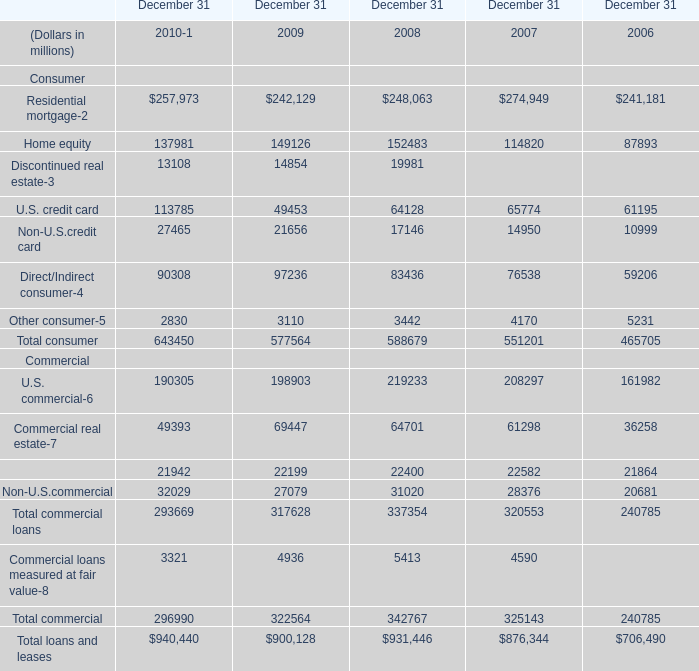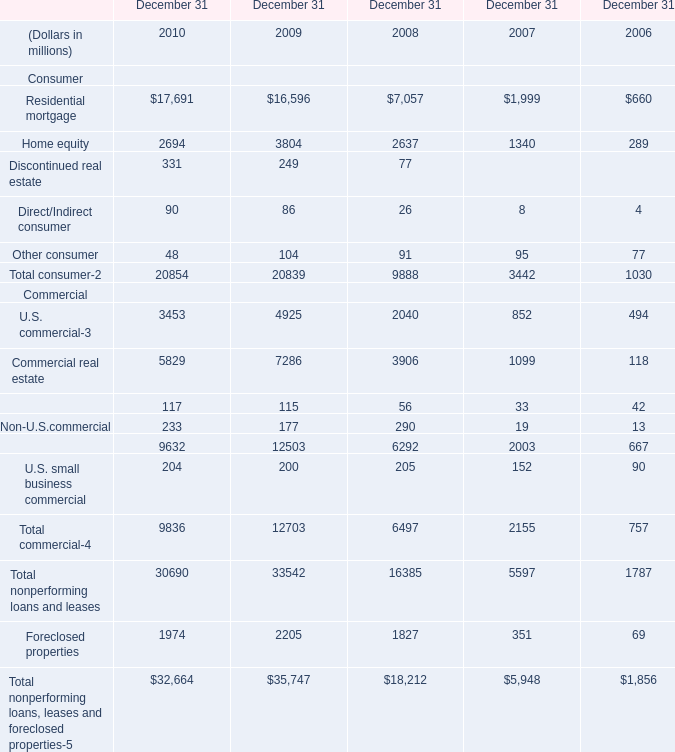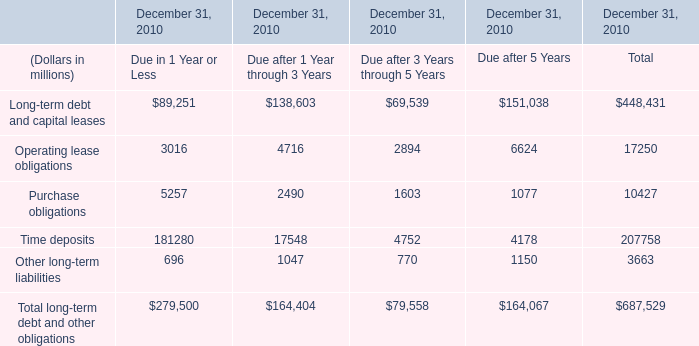What's the average of Home equity in 2010, 2009, and 2008? (in millions) 
Computations: (((137981 + 149126) + 152483) / 3)
Answer: 146530.0. 